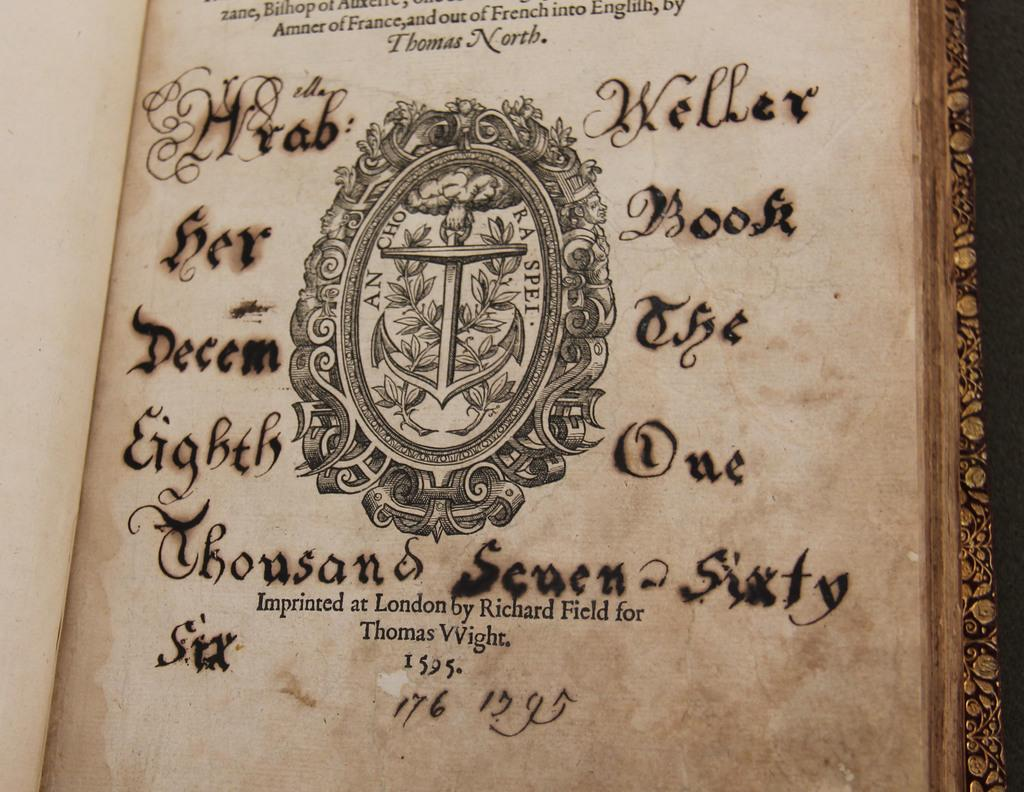<image>
Present a compact description of the photo's key features. Hrab Weller owned this book in December of 1766. 